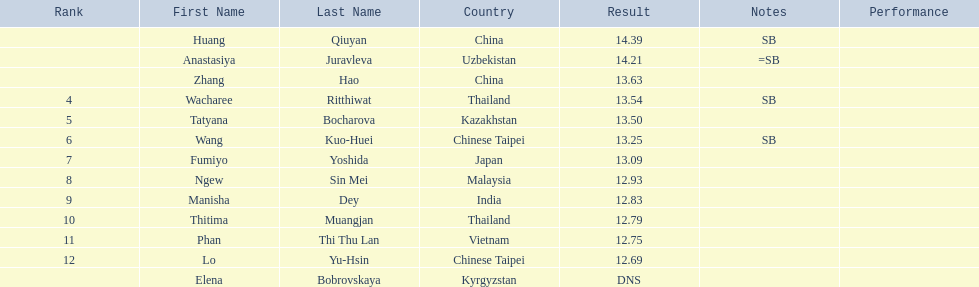How many competitors had less than 13.00 points? 6. 